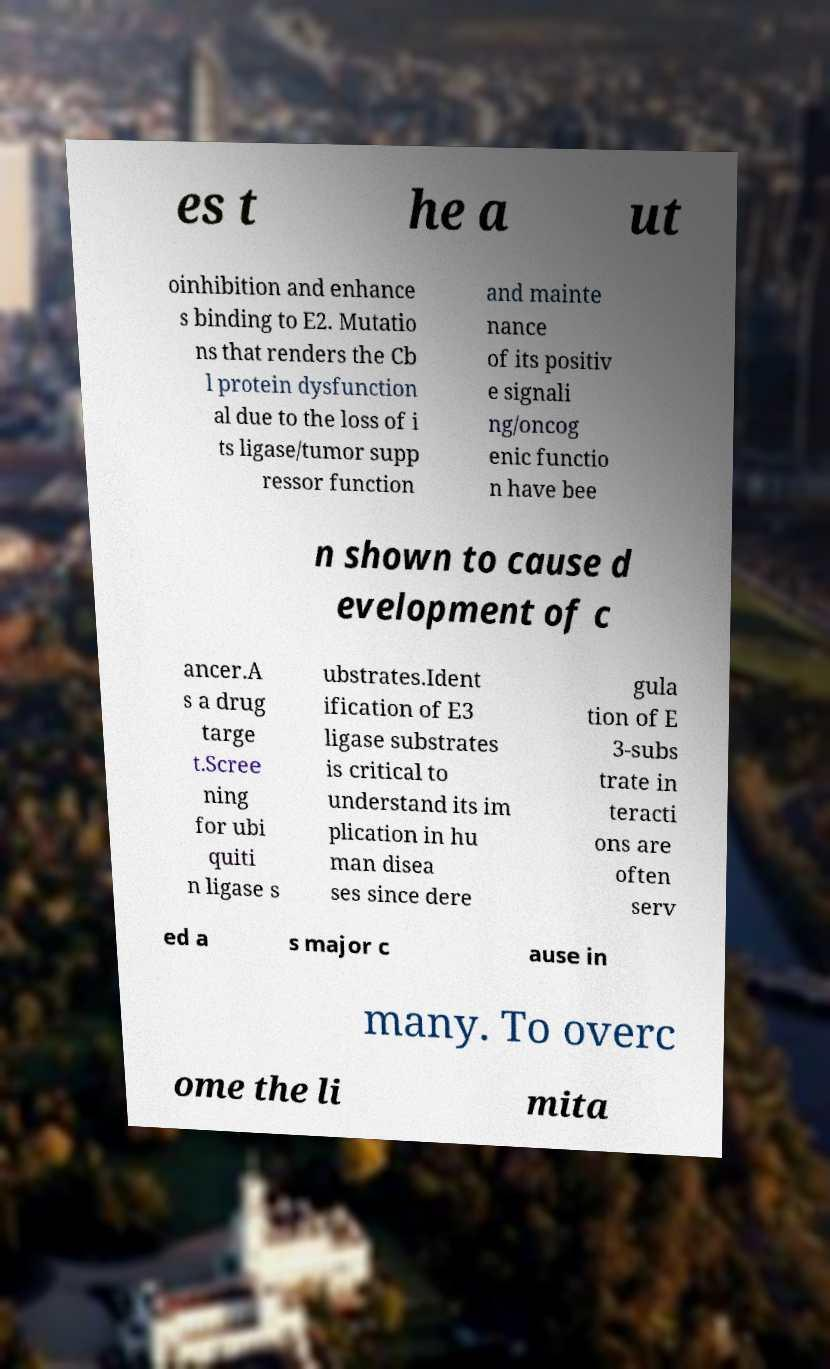Can you accurately transcribe the text from the provided image for me? es t he a ut oinhibition and enhance s binding to E2. Mutatio ns that renders the Cb l protein dysfunction al due to the loss of i ts ligase/tumor supp ressor function and mainte nance of its positiv e signali ng/oncog enic functio n have bee n shown to cause d evelopment of c ancer.A s a drug targe t.Scree ning for ubi quiti n ligase s ubstrates.Ident ification of E3 ligase substrates is critical to understand its im plication in hu man disea ses since dere gula tion of E 3-subs trate in teracti ons are often serv ed a s major c ause in many. To overc ome the li mita 